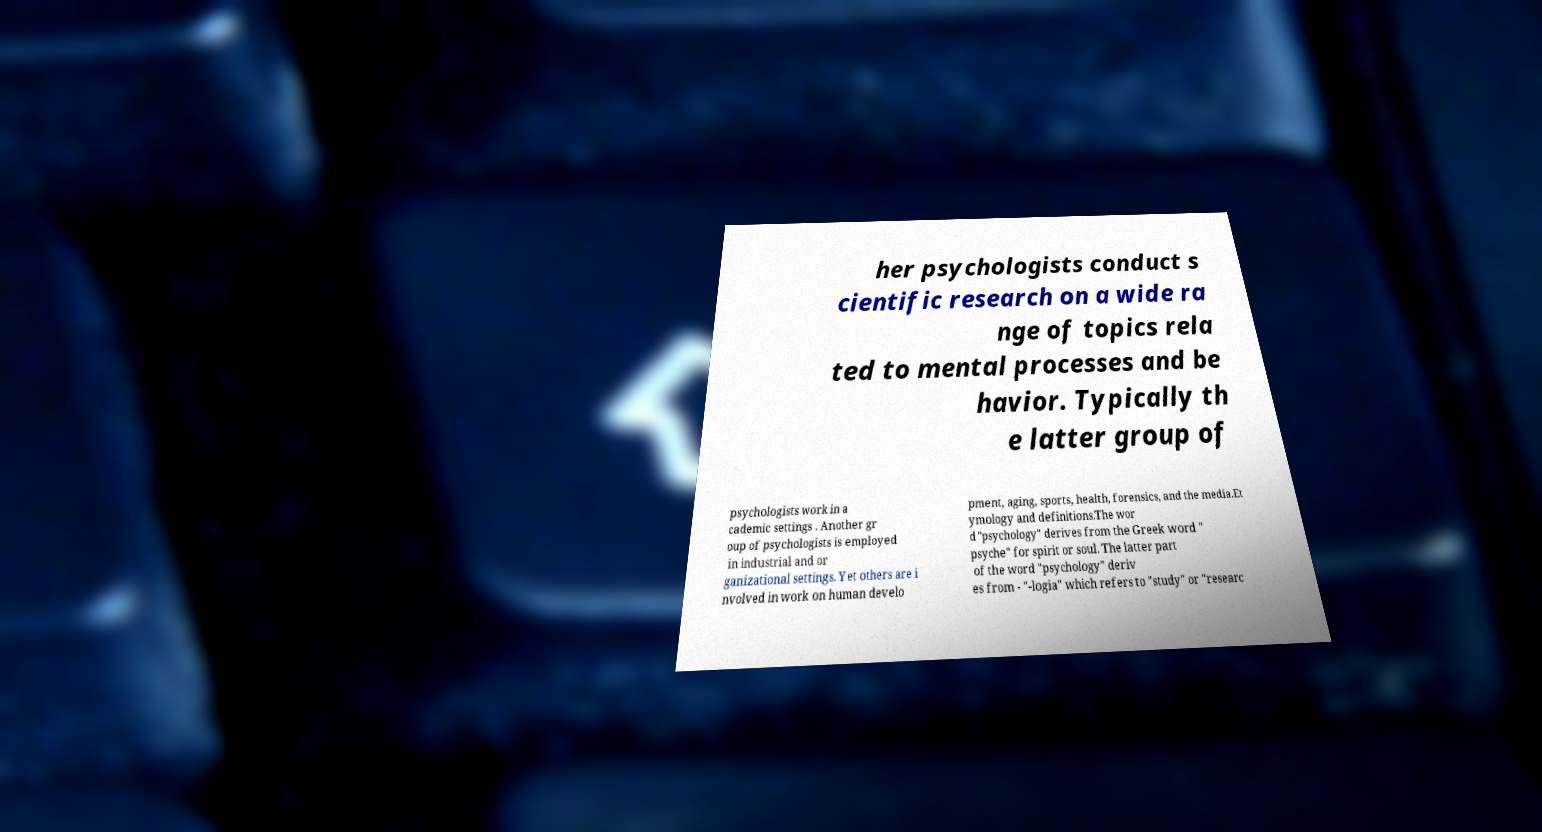Can you accurately transcribe the text from the provided image for me? her psychologists conduct s cientific research on a wide ra nge of topics rela ted to mental processes and be havior. Typically th e latter group of psychologists work in a cademic settings . Another gr oup of psychologists is employed in industrial and or ganizational settings. Yet others are i nvolved in work on human develo pment, aging, sports, health, forensics, and the media.Et ymology and definitions.The wor d "psychology" derives from the Greek word " psyche" for spirit or soul. The latter part of the word "psychology" deriv es from - "-logia" which refers to "study" or "researc 